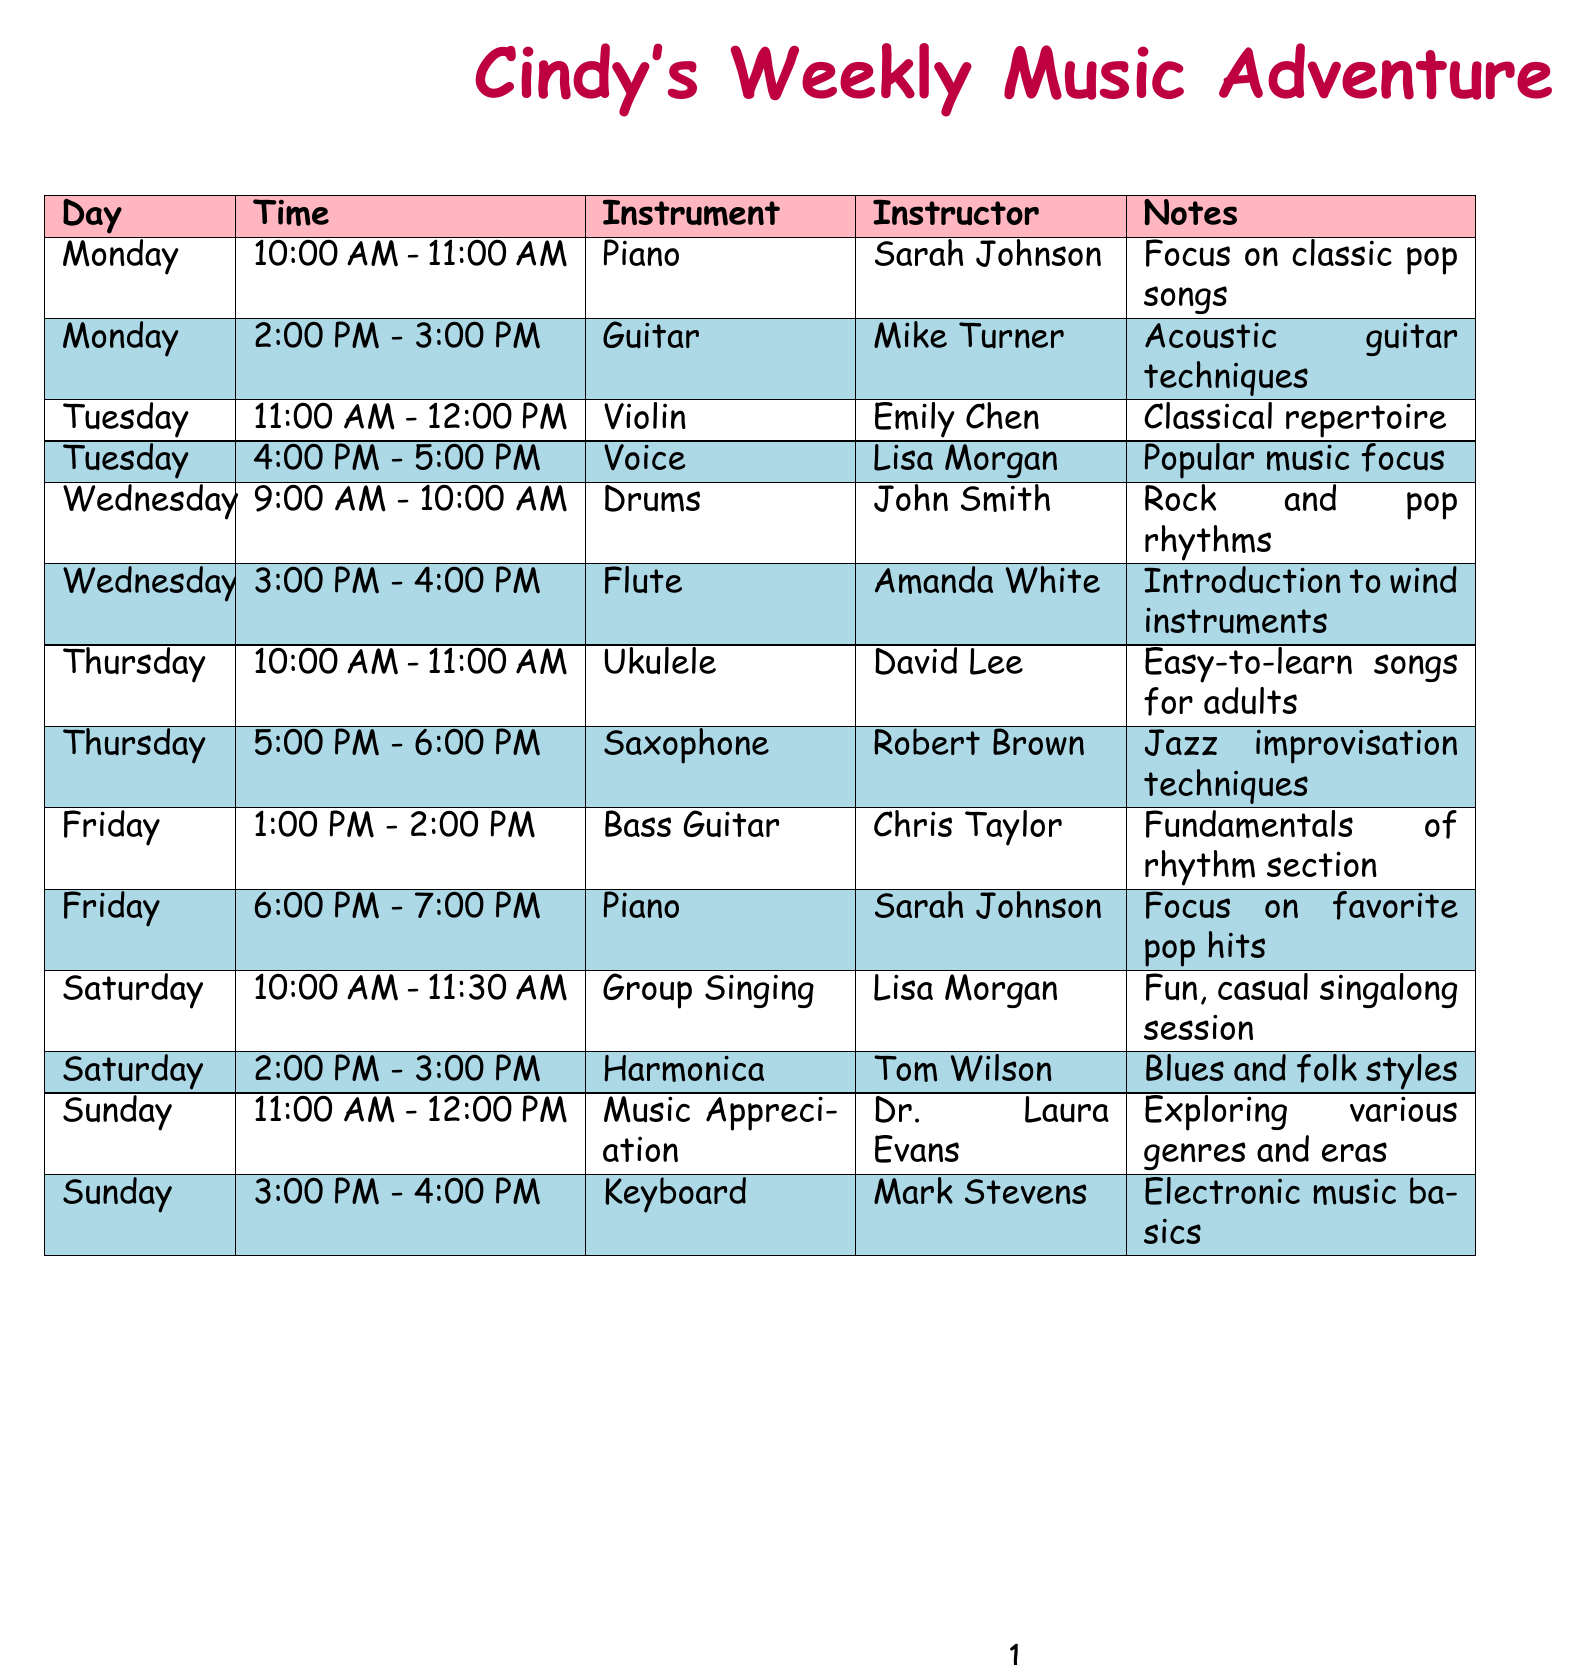what instrument is taught by Sarah Johnson on Monday? Sarah Johnson teaches Piano on Monday at 10:00 AM - 11:00 AM.
Answer: Piano how many lessons are scheduled on Saturday? There are two lessons scheduled on Saturday: Group Singing and Harmonica.
Answer: 2 who teaches the Violin on Tuesday? The instructor for Violin on Tuesday at 11:00 AM is Emily Chen.
Answer: Emily Chen what is the focus of the beginner's workshop? The beginner's workshop focuses on helping beginners read and understand musical notation.
Answer: Understanding Sheet Music which instrument has lessons scheduled for two different levels on Friday? Piano has both Beginner and Intermediate levels scheduled on Friday.
Answer: Piano 